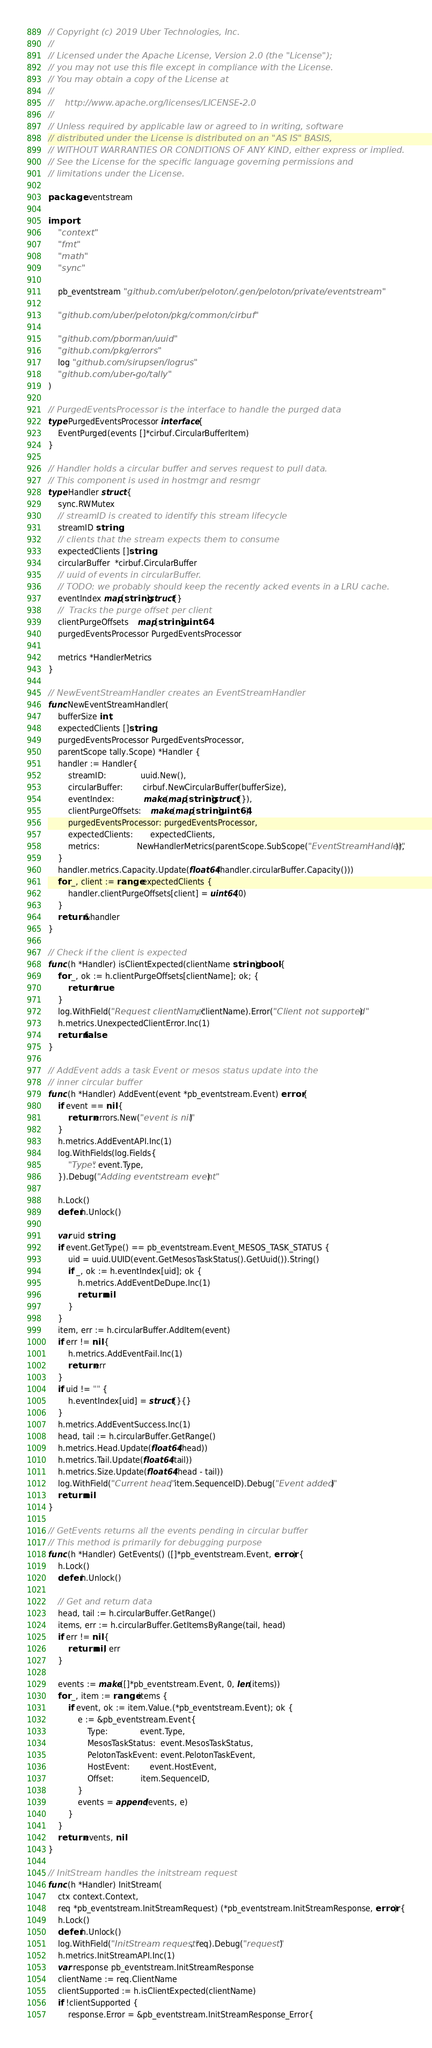Convert code to text. <code><loc_0><loc_0><loc_500><loc_500><_Go_>// Copyright (c) 2019 Uber Technologies, Inc.
//
// Licensed under the Apache License, Version 2.0 (the "License");
// you may not use this file except in compliance with the License.
// You may obtain a copy of the License at
//
//    http://www.apache.org/licenses/LICENSE-2.0
//
// Unless required by applicable law or agreed to in writing, software
// distributed under the License is distributed on an "AS IS" BASIS,
// WITHOUT WARRANTIES OR CONDITIONS OF ANY KIND, either express or implied.
// See the License for the specific language governing permissions and
// limitations under the License.

package eventstream

import (
	"context"
	"fmt"
	"math"
	"sync"

	pb_eventstream "github.com/uber/peloton/.gen/peloton/private/eventstream"

	"github.com/uber/peloton/pkg/common/cirbuf"

	"github.com/pborman/uuid"
	"github.com/pkg/errors"
	log "github.com/sirupsen/logrus"
	"github.com/uber-go/tally"
)

// PurgedEventsProcessor is the interface to handle the purged data
type PurgedEventsProcessor interface {
	EventPurged(events []*cirbuf.CircularBufferItem)
}

// Handler holds a circular buffer and serves request to pull data.
// This component is used in hostmgr and resmgr
type Handler struct {
	sync.RWMutex
	// streamID is created to identify this stream lifecycle
	streamID string
	// clients that the stream expects them to consume
	expectedClients []string
	circularBuffer  *cirbuf.CircularBuffer
	// uuid of events in circularBuffer.
	// TODO: we probably should keep the recently acked events in a LRU cache.
	eventIndex map[string]struct{}
	//  Tracks the purge offset per client
	clientPurgeOffsets    map[string]uint64
	purgedEventsProcessor PurgedEventsProcessor

	metrics *HandlerMetrics
}

// NewEventStreamHandler creates an EventStreamHandler
func NewEventStreamHandler(
	bufferSize int,
	expectedClients []string,
	purgedEventsProcessor PurgedEventsProcessor,
	parentScope tally.Scope) *Handler {
	handler := Handler{
		streamID:              uuid.New(),
		circularBuffer:        cirbuf.NewCircularBuffer(bufferSize),
		eventIndex:            make(map[string]struct{}),
		clientPurgeOffsets:    make(map[string]uint64),
		purgedEventsProcessor: purgedEventsProcessor,
		expectedClients:       expectedClients,
		metrics:               NewHandlerMetrics(parentScope.SubScope("EventStreamHandler")),
	}
	handler.metrics.Capacity.Update(float64(handler.circularBuffer.Capacity()))
	for _, client := range expectedClients {
		handler.clientPurgeOffsets[client] = uint64(0)
	}
	return &handler
}

// Check if the client is expected
func (h *Handler) isClientExpected(clientName string) bool {
	for _, ok := h.clientPurgeOffsets[clientName]; ok; {
		return true
	}
	log.WithField("Request clientName", clientName).Error("Client not supported")
	h.metrics.UnexpectedClientError.Inc(1)
	return false
}

// AddEvent adds a task Event or mesos status update into the
// inner circular buffer
func (h *Handler) AddEvent(event *pb_eventstream.Event) error {
	if event == nil {
		return errors.New("event is nil")
	}
	h.metrics.AddEventAPI.Inc(1)
	log.WithFields(log.Fields{
		"Type": event.Type,
	}).Debug("Adding eventstream event")

	h.Lock()
	defer h.Unlock()

	var uid string
	if event.GetType() == pb_eventstream.Event_MESOS_TASK_STATUS {
		uid = uuid.UUID(event.GetMesosTaskStatus().GetUuid()).String()
		if _, ok := h.eventIndex[uid]; ok {
			h.metrics.AddEventDeDupe.Inc(1)
			return nil
		}
	}
	item, err := h.circularBuffer.AddItem(event)
	if err != nil {
		h.metrics.AddEventFail.Inc(1)
		return err
	}
	if uid != "" {
		h.eventIndex[uid] = struct{}{}
	}
	h.metrics.AddEventSuccess.Inc(1)
	head, tail := h.circularBuffer.GetRange()
	h.metrics.Head.Update(float64(head))
	h.metrics.Tail.Update(float64(tail))
	h.metrics.Size.Update(float64(head - tail))
	log.WithField("Current head", item.SequenceID).Debug("Event added")
	return nil
}

// GetEvents returns all the events pending in circular buffer
// This method is primarily for debugging purpose
func (h *Handler) GetEvents() ([]*pb_eventstream.Event, error) {
	h.Lock()
	defer h.Unlock()

	// Get and return data
	head, tail := h.circularBuffer.GetRange()
	items, err := h.circularBuffer.GetItemsByRange(tail, head)
	if err != nil {
		return nil, err
	}

	events := make([]*pb_eventstream.Event, 0, len(items))
	for _, item := range items {
		if event, ok := item.Value.(*pb_eventstream.Event); ok {
			e := &pb_eventstream.Event{
				Type:             event.Type,
				MesosTaskStatus:  event.MesosTaskStatus,
				PelotonTaskEvent: event.PelotonTaskEvent,
				HostEvent:        event.HostEvent,
				Offset:           item.SequenceID,
			}
			events = append(events, e)
		}
	}
	return events, nil
}

// InitStream handles the initstream request
func (h *Handler) InitStream(
	ctx context.Context,
	req *pb_eventstream.InitStreamRequest) (*pb_eventstream.InitStreamResponse, error) {
	h.Lock()
	defer h.Unlock()
	log.WithField("InitStream request", req).Debug("request")
	h.metrics.InitStreamAPI.Inc(1)
	var response pb_eventstream.InitStreamResponse
	clientName := req.ClientName
	clientSupported := h.isClientExpected(clientName)
	if !clientSupported {
		response.Error = &pb_eventstream.InitStreamResponse_Error{</code> 